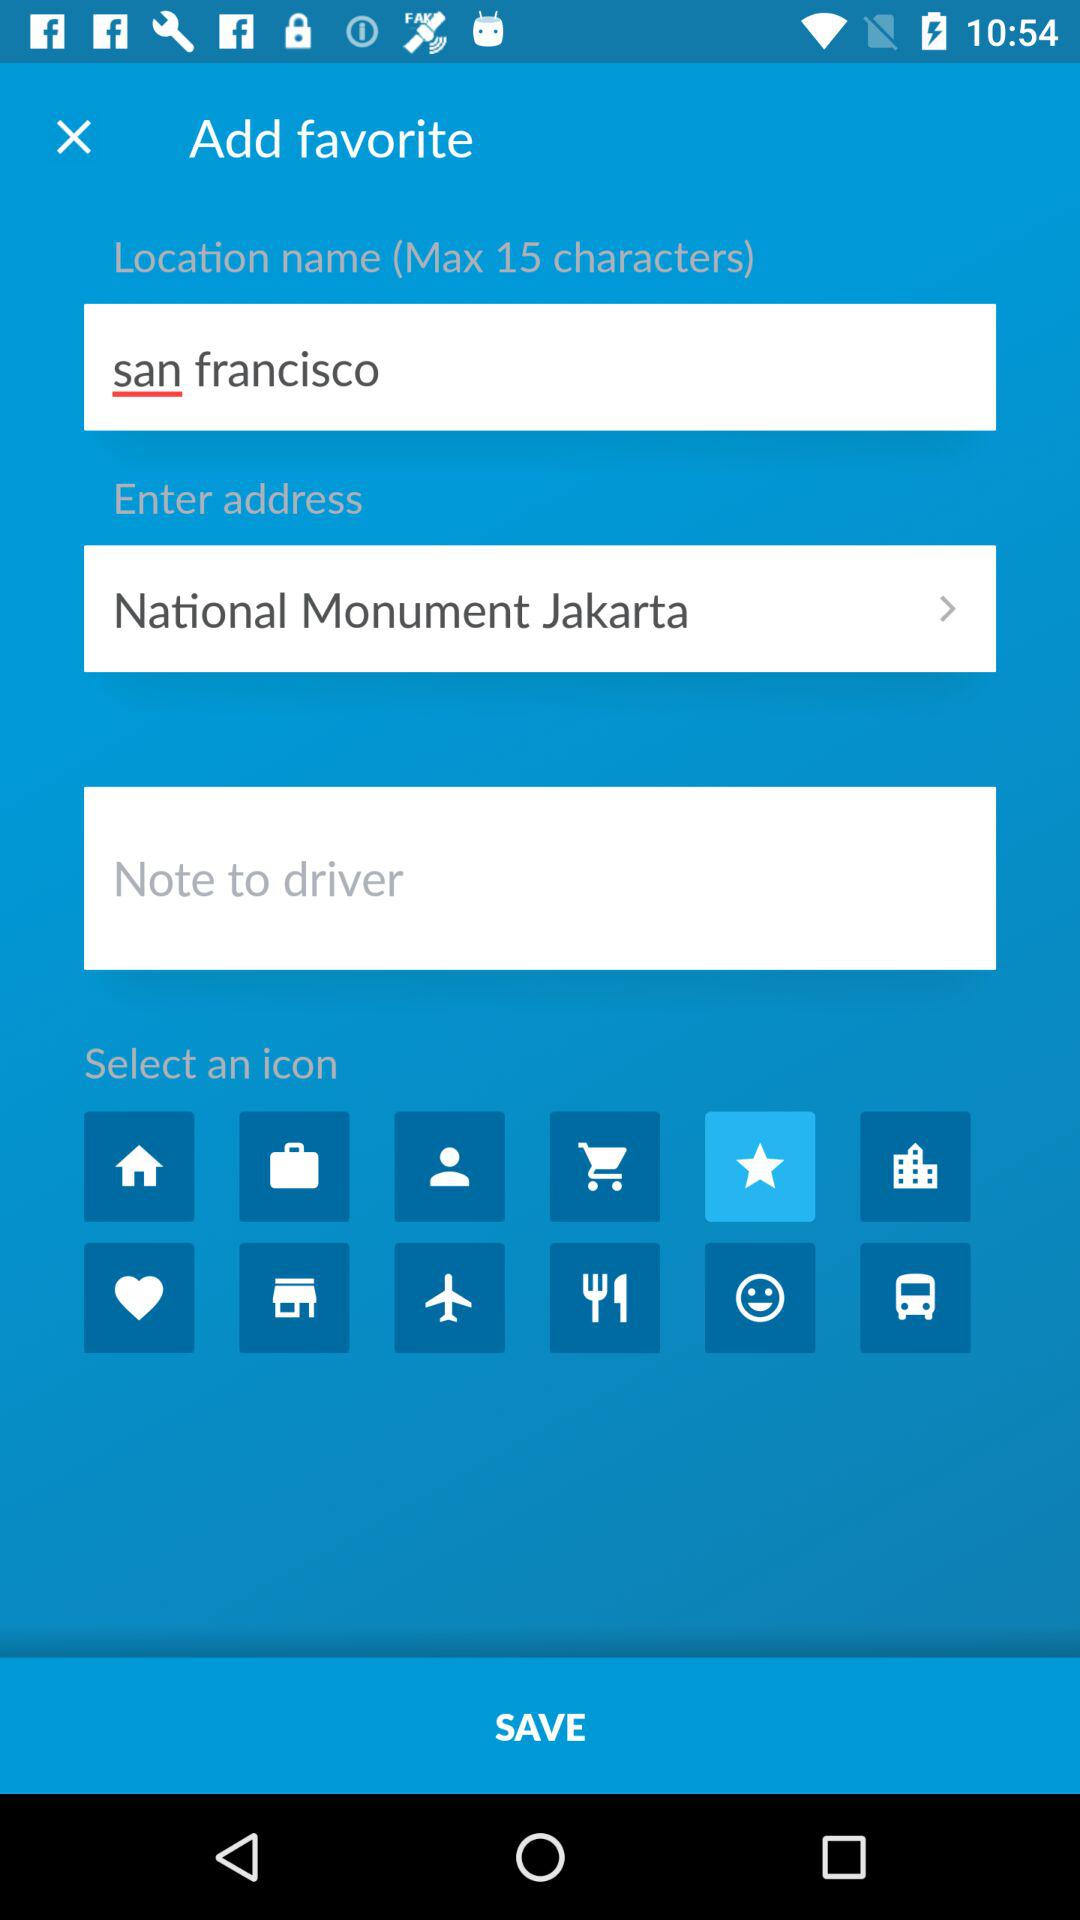What is the maximum number of characters that can be entered into the location name? The maximum number of characters that can be entered is 15. 